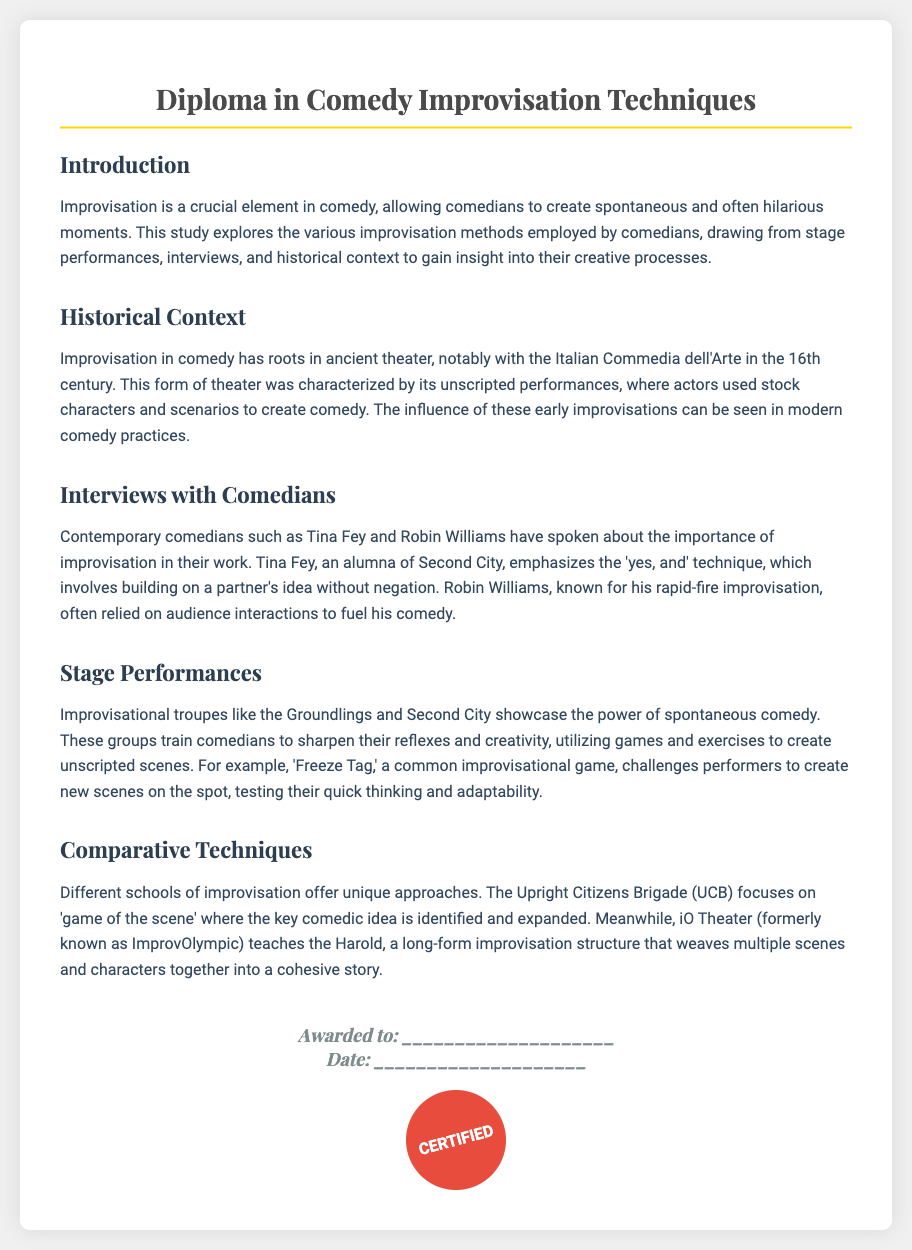what is the title of the diploma? The title reflects the content and focus of the study on comedy improvisation techniques.
Answer: Diploma in Comedy Improvisation Techniques who is a contemporary comedian mentioned in the interviews section? This information is found in the section discussing interviews with comedians highlighting their improvisation insights.
Answer: Tina Fey what improvisational game challenges performers to create new scenes on the spot? The game is referenced in the stage performances section as a method for sharpening improvisational skills.
Answer: Freeze Tag what improvisational troupe is known for its spontaneous comedy? The document identifies specific troupes that are prominent in the field of improvisational comedy.
Answer: Groundlings what technique does Tina Fey emphasize in her work? The document highlights a specific improvisational technique that encourages collaborative idea building.
Answer: yes, and what historical form of theater influenced modern improvisation? This refers to the origins of improvisational comedy tracing back to a certain theatrical tradition.
Answer: Commedia dell'Arte what long-form improvisation structure is taught at iO Theater? The document specifies a particular structure associated with the iO Theater.
Answer: Harold how many sections are in the diploma? This is based on the content structure as outlined in the document, counting the main topics presented.
Answer: Five 